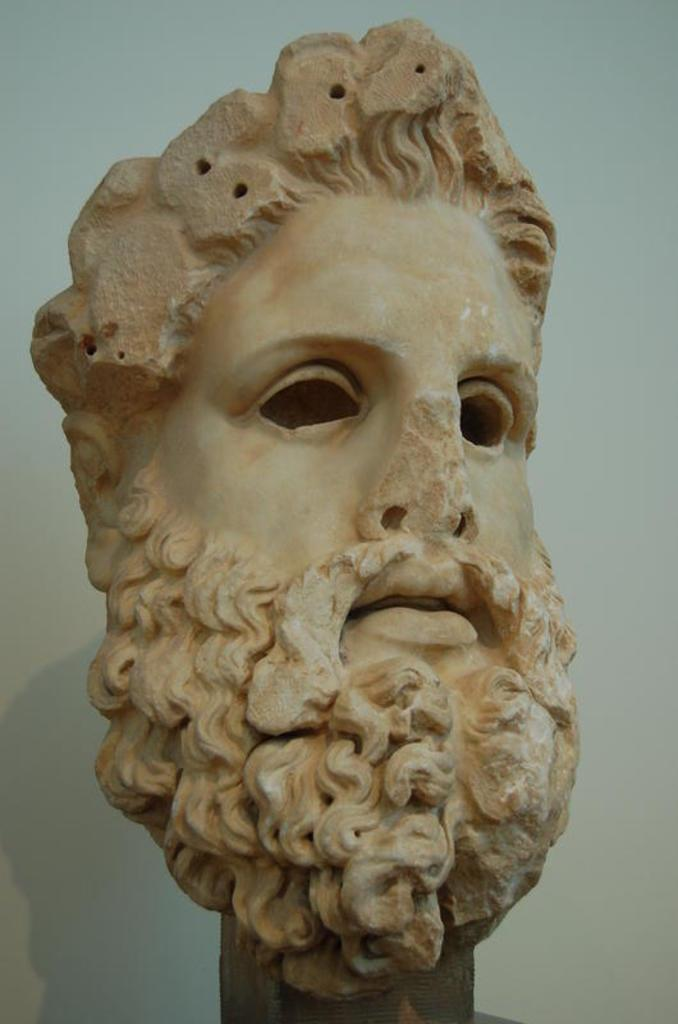What is the main subject of the image? The main subject of the image is a sculpture. Can you describe the sculpture in the image? The sculpture is of a man. What facial feature does the man depicted in the sculpture have? The man depicted in the sculpture has a beard. What type of chalk is the man using to write his name on the pot in the image? There is no chalk, man writing his name, or pot present in the image. 